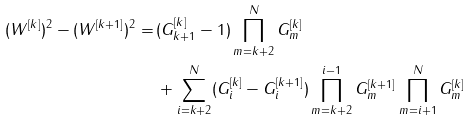<formula> <loc_0><loc_0><loc_500><loc_500>( W ^ { [ k ] } ) ^ { 2 } - ( W ^ { [ k + 1 ] } ) ^ { 2 } = \, & ( G _ { k + 1 } ^ { [ k ] } - 1 ) \prod _ { m = k + 2 } ^ { N } G ^ { [ k ] } _ { m } \\ & + \sum _ { i = k + 2 } ^ { N } ( G _ { i } ^ { [ k ] } - G _ { i } ^ { [ k + 1 ] } ) \prod _ { m = k + 2 } ^ { i - 1 } G _ { m } ^ { [ k + 1 ] } \prod _ { m = i + 1 } ^ { N } G _ { m } ^ { [ k ] } \,</formula> 